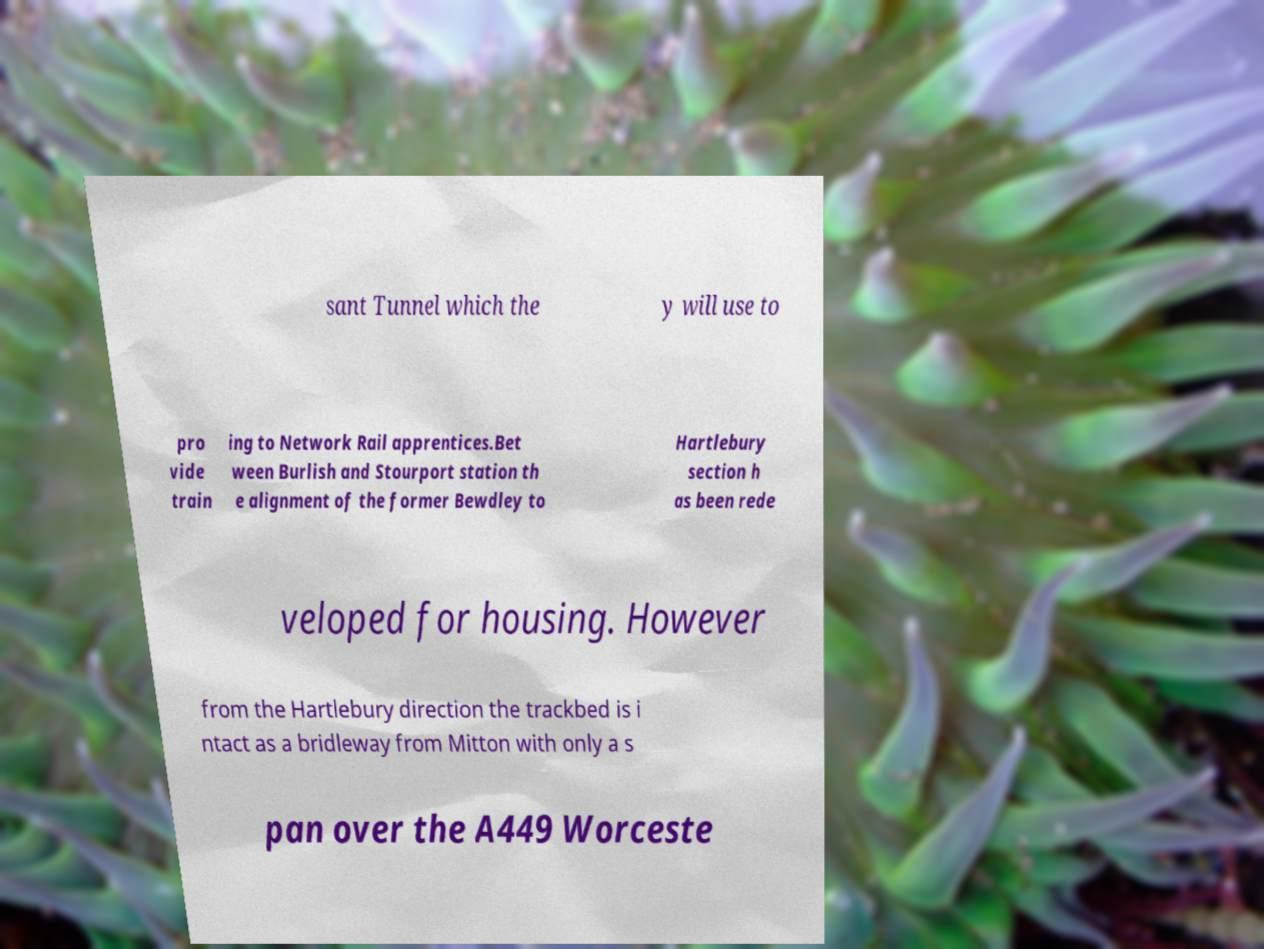Please identify and transcribe the text found in this image. sant Tunnel which the y will use to pro vide train ing to Network Rail apprentices.Bet ween Burlish and Stourport station th e alignment of the former Bewdley to Hartlebury section h as been rede veloped for housing. However from the Hartlebury direction the trackbed is i ntact as a bridleway from Mitton with only a s pan over the A449 Worceste 